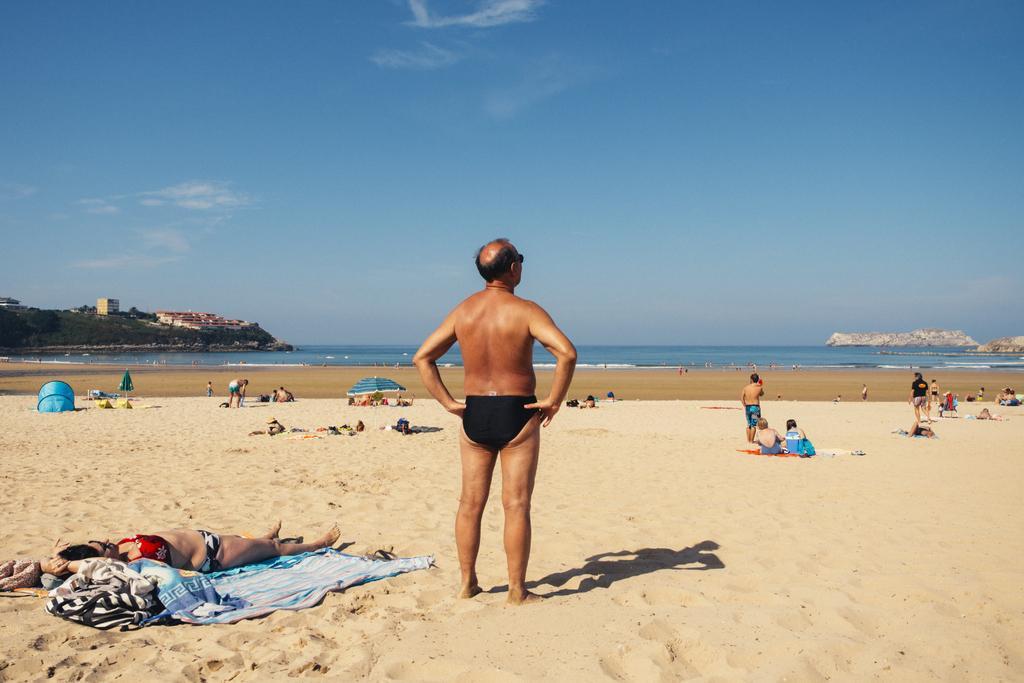Can you describe this image briefly? In the foreground of this picture, there is a man standing on the sand. In the background, we can see persons on the sand , water, buildings, trees, sky and the cloud. 